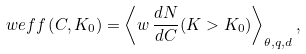Convert formula to latex. <formula><loc_0><loc_0><loc_500><loc_500>\ w e f f \left ( C , K _ { 0 } \right ) = \left \langle w \, \frac { d N } { d C } ( K > K _ { 0 } ) \right \rangle _ { \theta , q , d } ,</formula> 